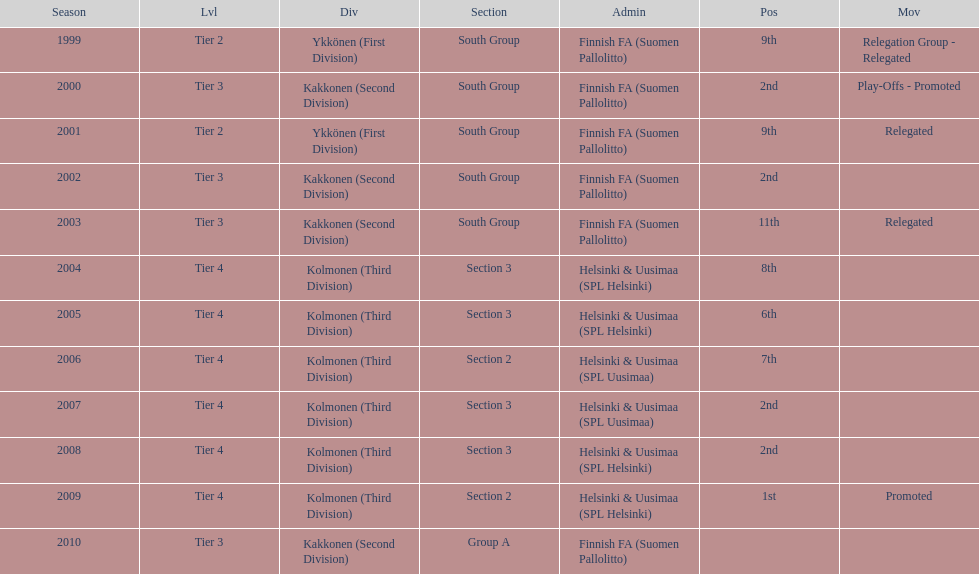How many tiers had more than one relegated movement? 1. 